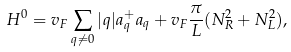Convert formula to latex. <formula><loc_0><loc_0><loc_500><loc_500>H ^ { 0 } = v _ { F } \sum _ { q \ne 0 } | q | a _ { q } ^ { + } a _ { q } + v _ { F } \frac { \pi } { L } ( N _ { R } ^ { 2 } + N _ { L } ^ { 2 } ) ,</formula> 